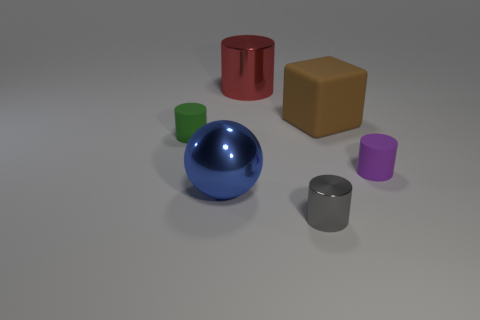Add 3 cylinders. How many objects exist? 9 Subtract all red cylinders. How many cylinders are left? 3 Subtract all tiny purple cylinders. How many cylinders are left? 3 Subtract all spheres. How many objects are left? 5 Subtract 1 blocks. How many blocks are left? 0 Add 6 metallic objects. How many metallic objects are left? 9 Add 1 large red metal cylinders. How many large red metal cylinders exist? 2 Subtract 1 green cylinders. How many objects are left? 5 Subtract all green cylinders. Subtract all gray spheres. How many cylinders are left? 3 Subtract all green cubes. How many purple cylinders are left? 1 